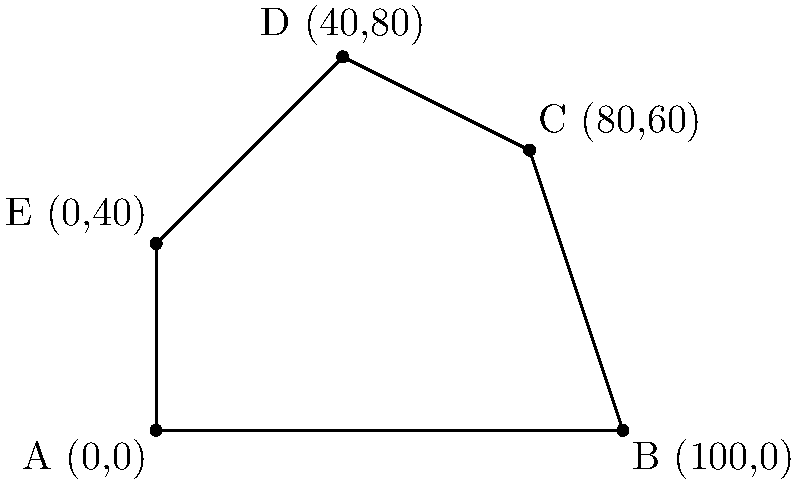You've been asked to calculate the area of an irregularly shaped lot for a new construction project. The lot's boundaries are defined by the following coordinate points: A(0,0), B(100,0), C(80,60), D(40,80), and E(0,40). Using the coordinate geometry method, determine the area of this lot in square feet. Round your answer to the nearest whole number. To calculate the area of this irregular polygon, we'll use the Shoelace formula (also known as the surveyor's formula). Here's how:

1) First, let's arrange the points in order: (0,0), (100,0), (80,60), (40,80), (0,40)

2) The formula is:
   Area = $\frac{1}{2}|((x_1y_2 + x_2y_3 + ... + x_ny_1) - (y_1x_2 + y_2x_3 + ... + y_nx_1))|$

3) Let's calculate each part:
   $(x_1y_2 + x_2y_3 + ... + x_ny_1)$:
   $(0 \cdot 0) + (100 \cdot 60) + (80 \cdot 80) + (40 \cdot 40) + (0 \cdot 0) = 6000 + 6400 + 1600 = 14000$

   $(y_1x_2 + y_2x_3 + ... + y_nx_1)$:
   $(0 \cdot 100) + (0 \cdot 80) + (60 \cdot 40) + (80 \cdot 0) + (40 \cdot 0) = 2400$

4) Now, let's subtract:
   $14000 - 2400 = 11600$

5) Divide by 2:
   $\frac{11600}{2} = 5800$

Therefore, the area of the lot is 5,800 square feet.
Answer: 5,800 sq ft 